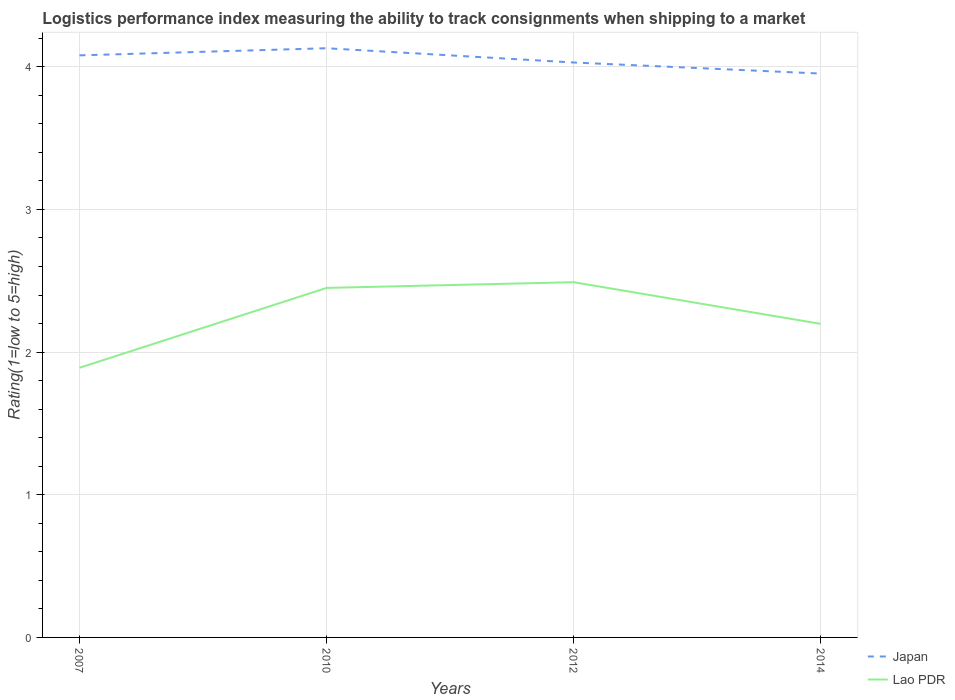How many different coloured lines are there?
Keep it short and to the point. 2. Is the number of lines equal to the number of legend labels?
Provide a short and direct response. Yes. Across all years, what is the maximum Logistic performance index in Lao PDR?
Give a very brief answer. 1.89. In which year was the Logistic performance index in Japan maximum?
Your answer should be compact. 2014. What is the total Logistic performance index in Lao PDR in the graph?
Your answer should be compact. 0.25. What is the difference between the highest and the second highest Logistic performance index in Lao PDR?
Offer a very short reply. 0.6. Is the Logistic performance index in Japan strictly greater than the Logistic performance index in Lao PDR over the years?
Keep it short and to the point. No. How many lines are there?
Provide a succinct answer. 2. Does the graph contain grids?
Keep it short and to the point. Yes. Where does the legend appear in the graph?
Provide a short and direct response. Bottom right. How are the legend labels stacked?
Your answer should be very brief. Vertical. What is the title of the graph?
Offer a very short reply. Logistics performance index measuring the ability to track consignments when shipping to a market. What is the label or title of the Y-axis?
Keep it short and to the point. Rating(1=low to 5=high). What is the Rating(1=low to 5=high) in Japan in 2007?
Your response must be concise. 4.08. What is the Rating(1=low to 5=high) in Lao PDR in 2007?
Give a very brief answer. 1.89. What is the Rating(1=low to 5=high) of Japan in 2010?
Give a very brief answer. 4.13. What is the Rating(1=low to 5=high) in Lao PDR in 2010?
Ensure brevity in your answer.  2.45. What is the Rating(1=low to 5=high) in Japan in 2012?
Provide a short and direct response. 4.03. What is the Rating(1=low to 5=high) of Lao PDR in 2012?
Give a very brief answer. 2.49. What is the Rating(1=low to 5=high) in Japan in 2014?
Your response must be concise. 3.95. What is the Rating(1=low to 5=high) of Lao PDR in 2014?
Your response must be concise. 2.2. Across all years, what is the maximum Rating(1=low to 5=high) in Japan?
Offer a very short reply. 4.13. Across all years, what is the maximum Rating(1=low to 5=high) in Lao PDR?
Your answer should be very brief. 2.49. Across all years, what is the minimum Rating(1=low to 5=high) of Japan?
Give a very brief answer. 3.95. Across all years, what is the minimum Rating(1=low to 5=high) in Lao PDR?
Your response must be concise. 1.89. What is the total Rating(1=low to 5=high) of Japan in the graph?
Give a very brief answer. 16.19. What is the total Rating(1=low to 5=high) of Lao PDR in the graph?
Your answer should be very brief. 9.03. What is the difference between the Rating(1=low to 5=high) in Japan in 2007 and that in 2010?
Give a very brief answer. -0.05. What is the difference between the Rating(1=low to 5=high) in Lao PDR in 2007 and that in 2010?
Your answer should be compact. -0.56. What is the difference between the Rating(1=low to 5=high) of Lao PDR in 2007 and that in 2012?
Ensure brevity in your answer.  -0.6. What is the difference between the Rating(1=low to 5=high) of Japan in 2007 and that in 2014?
Ensure brevity in your answer.  0.13. What is the difference between the Rating(1=low to 5=high) of Lao PDR in 2007 and that in 2014?
Make the answer very short. -0.31. What is the difference between the Rating(1=low to 5=high) of Lao PDR in 2010 and that in 2012?
Your answer should be compact. -0.04. What is the difference between the Rating(1=low to 5=high) in Japan in 2010 and that in 2014?
Your answer should be very brief. 0.18. What is the difference between the Rating(1=low to 5=high) of Lao PDR in 2010 and that in 2014?
Offer a very short reply. 0.25. What is the difference between the Rating(1=low to 5=high) of Japan in 2012 and that in 2014?
Ensure brevity in your answer.  0.08. What is the difference between the Rating(1=low to 5=high) of Lao PDR in 2012 and that in 2014?
Ensure brevity in your answer.  0.29. What is the difference between the Rating(1=low to 5=high) of Japan in 2007 and the Rating(1=low to 5=high) of Lao PDR in 2010?
Give a very brief answer. 1.63. What is the difference between the Rating(1=low to 5=high) of Japan in 2007 and the Rating(1=low to 5=high) of Lao PDR in 2012?
Provide a succinct answer. 1.59. What is the difference between the Rating(1=low to 5=high) of Japan in 2007 and the Rating(1=low to 5=high) of Lao PDR in 2014?
Your answer should be compact. 1.88. What is the difference between the Rating(1=low to 5=high) in Japan in 2010 and the Rating(1=low to 5=high) in Lao PDR in 2012?
Offer a terse response. 1.64. What is the difference between the Rating(1=low to 5=high) in Japan in 2010 and the Rating(1=low to 5=high) in Lao PDR in 2014?
Your response must be concise. 1.93. What is the difference between the Rating(1=low to 5=high) of Japan in 2012 and the Rating(1=low to 5=high) of Lao PDR in 2014?
Provide a short and direct response. 1.83. What is the average Rating(1=low to 5=high) in Japan per year?
Keep it short and to the point. 4.05. What is the average Rating(1=low to 5=high) of Lao PDR per year?
Your answer should be compact. 2.26. In the year 2007, what is the difference between the Rating(1=low to 5=high) in Japan and Rating(1=low to 5=high) in Lao PDR?
Your answer should be very brief. 2.19. In the year 2010, what is the difference between the Rating(1=low to 5=high) in Japan and Rating(1=low to 5=high) in Lao PDR?
Your answer should be compact. 1.68. In the year 2012, what is the difference between the Rating(1=low to 5=high) in Japan and Rating(1=low to 5=high) in Lao PDR?
Your answer should be compact. 1.54. In the year 2014, what is the difference between the Rating(1=low to 5=high) in Japan and Rating(1=low to 5=high) in Lao PDR?
Make the answer very short. 1.75. What is the ratio of the Rating(1=low to 5=high) in Japan in 2007 to that in 2010?
Give a very brief answer. 0.99. What is the ratio of the Rating(1=low to 5=high) in Lao PDR in 2007 to that in 2010?
Your response must be concise. 0.77. What is the ratio of the Rating(1=low to 5=high) of Japan in 2007 to that in 2012?
Your answer should be very brief. 1.01. What is the ratio of the Rating(1=low to 5=high) of Lao PDR in 2007 to that in 2012?
Provide a succinct answer. 0.76. What is the ratio of the Rating(1=low to 5=high) of Japan in 2007 to that in 2014?
Offer a terse response. 1.03. What is the ratio of the Rating(1=low to 5=high) of Lao PDR in 2007 to that in 2014?
Provide a succinct answer. 0.86. What is the ratio of the Rating(1=low to 5=high) in Japan in 2010 to that in 2012?
Your answer should be very brief. 1.02. What is the ratio of the Rating(1=low to 5=high) of Lao PDR in 2010 to that in 2012?
Offer a terse response. 0.98. What is the ratio of the Rating(1=low to 5=high) in Japan in 2010 to that in 2014?
Make the answer very short. 1.04. What is the ratio of the Rating(1=low to 5=high) in Lao PDR in 2010 to that in 2014?
Provide a short and direct response. 1.11. What is the ratio of the Rating(1=low to 5=high) of Japan in 2012 to that in 2014?
Offer a very short reply. 1.02. What is the ratio of the Rating(1=low to 5=high) of Lao PDR in 2012 to that in 2014?
Provide a short and direct response. 1.13. What is the difference between the highest and the second highest Rating(1=low to 5=high) in Japan?
Provide a succinct answer. 0.05. What is the difference between the highest and the lowest Rating(1=low to 5=high) in Japan?
Provide a short and direct response. 0.18. What is the difference between the highest and the lowest Rating(1=low to 5=high) in Lao PDR?
Provide a succinct answer. 0.6. 